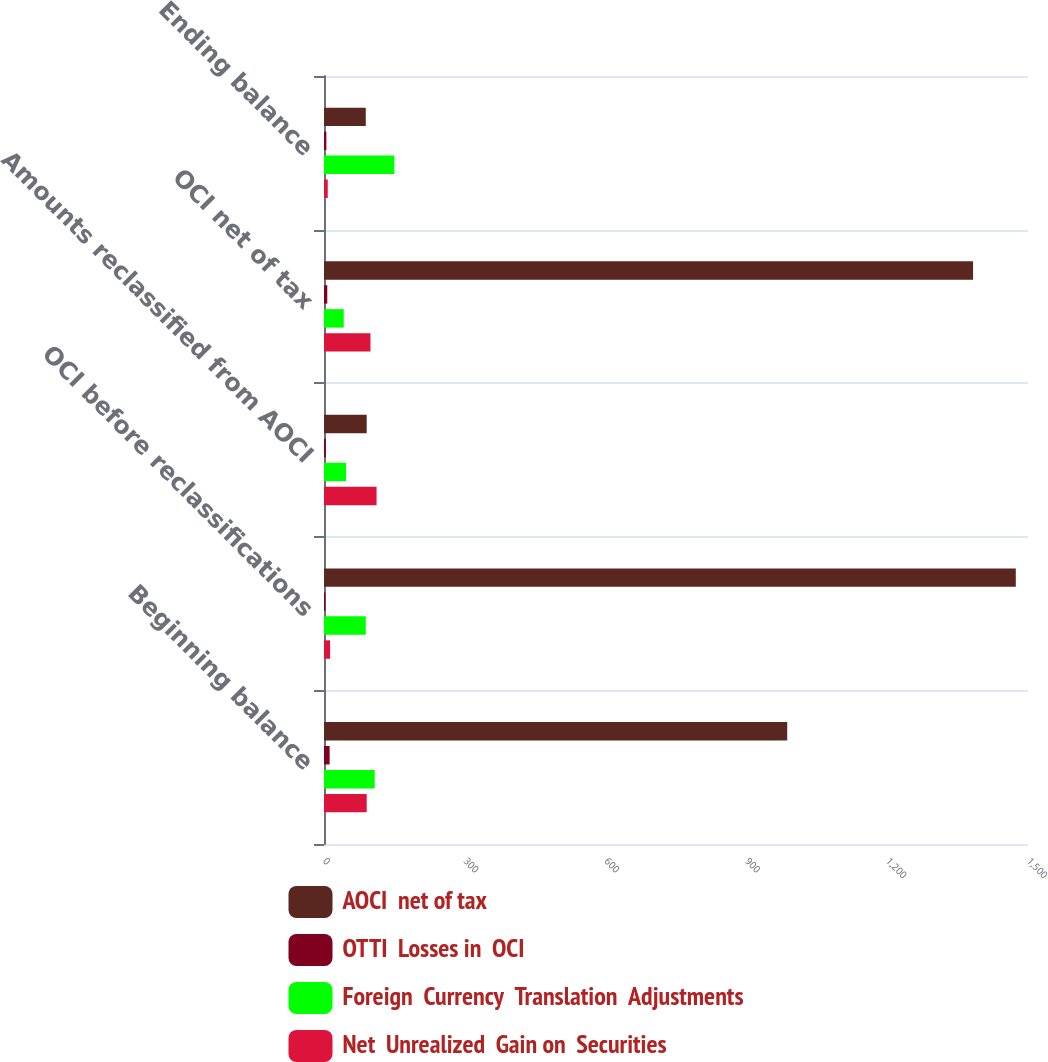Convert chart to OTSL. <chart><loc_0><loc_0><loc_500><loc_500><stacked_bar_chart><ecel><fcel>Beginning balance<fcel>OCI before reclassifications<fcel>Amounts reclassified from AOCI<fcel>OCI net of tax<fcel>Ending balance<nl><fcel>AOCI  net of tax<fcel>987<fcel>1474<fcel>91<fcel>1383<fcel>89<nl><fcel>OTTI  Losses in  OCI<fcel>12<fcel>3<fcel>4<fcel>7<fcel>5<nl><fcel>Foreign  Currency  Translation  Adjustments<fcel>108<fcel>89<fcel>47<fcel>42<fcel>150<nl><fcel>Net  Unrealized  Gain on  Securities<fcel>91<fcel>13<fcel>112<fcel>99<fcel>8<nl></chart> 